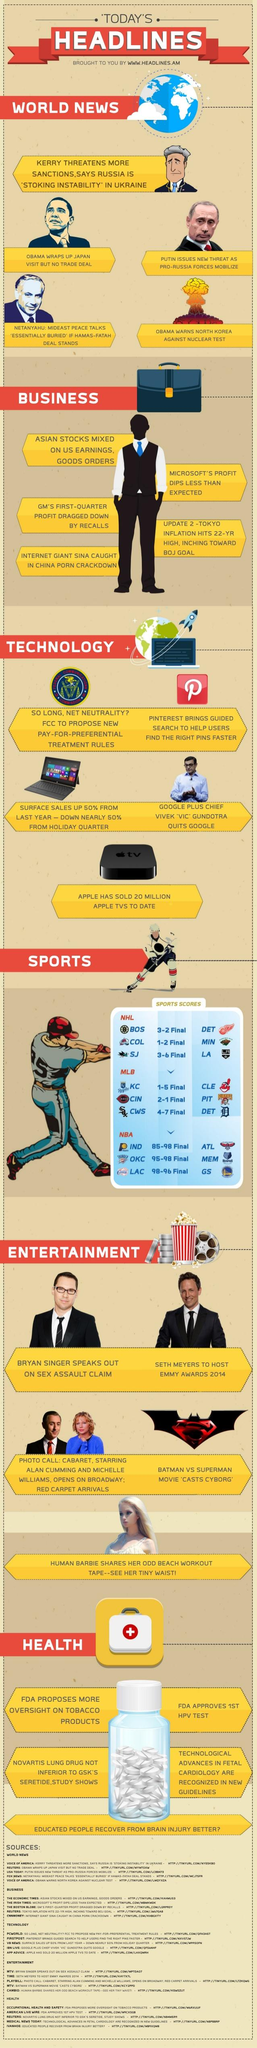Point out several critical features in this image. There are three types of games that fall under the heading of sports. There are 5 news articles under the heading "Business. This infographic contains six headlines. There are five news articles under the heading of "World News. There are 5 news articles under the heading "Technology. 